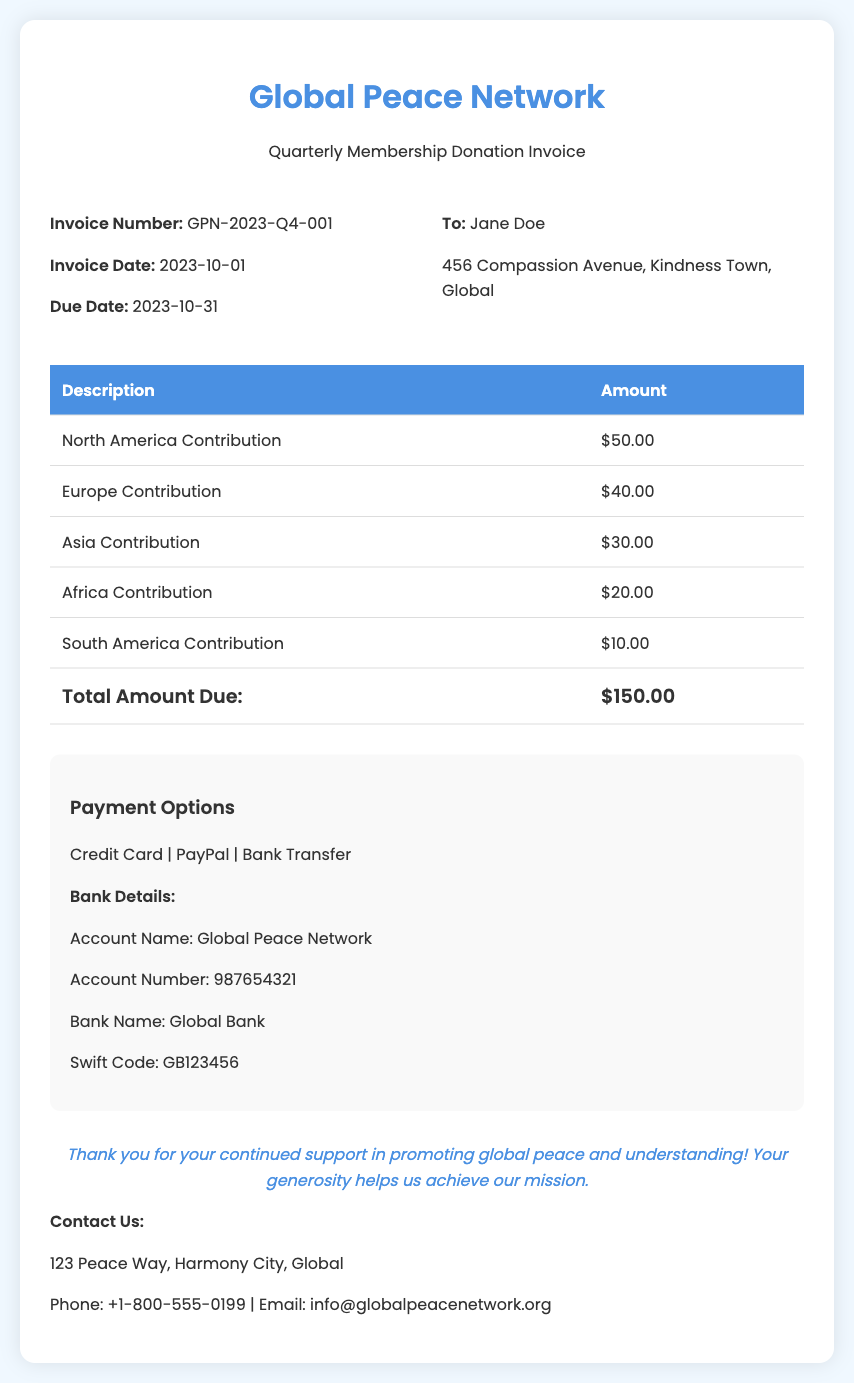What is the invoice number? The invoice number is clearly stated in the document for identification, which is GPN-2023-Q4-001.
Answer: GPN-2023-Q4-001 What is the total amount due? The total amount due is summarized in the footer of the invoice, which indicates the total contributions.
Answer: $150.00 What is the due date for the invoice? The due date is mentioned prominently in the invoice details for payment scheduling, which is 2023-10-31.
Answer: 2023-10-31 How much was contributed from North America? The amount contributed from North America is specifically listed in the table, which shows the contribution breakdown.
Answer: $50.00 Which payment options are available? The payment options are listed in the designated section, providing various methods for completing the payment.
Answer: Credit Card, PayPal, Bank Transfer Which organization does this invoice belong to? The invoice clearly displays the name of the organization at the top level, indicating ownership of the document.
Answer: Global Peace Network What is the address of the contact provided? The document includes the physical address for contacting the organization, a vital piece of information for communication.
Answer: 123 Peace Way, Harmony City, Global How many regions are listed for contributions? The regions listed show different geographical contributions, which can be counted in the contribution table.
Answer: Five What is the date of the invoice? The invoice date is noted in the document for reference, indicating when the invoice was issued.
Answer: 2023-10-01 